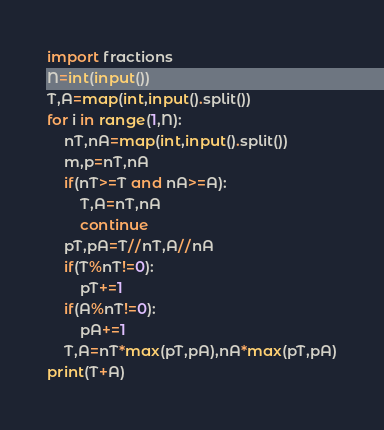<code> <loc_0><loc_0><loc_500><loc_500><_Python_>import fractions
N=int(input())
T,A=map(int,input().split())
for i in range(1,N):
    nT,nA=map(int,input().split())
    m,p=nT,nA
    if(nT>=T and nA>=A):
        T,A=nT,nA
        continue
    pT,pA=T//nT,A//nA
    if(T%nT!=0):
        pT+=1
    if(A%nT!=0):
        pA+=1
    T,A=nT*max(pT,pA),nA*max(pT,pA)
print(T+A)</code> 